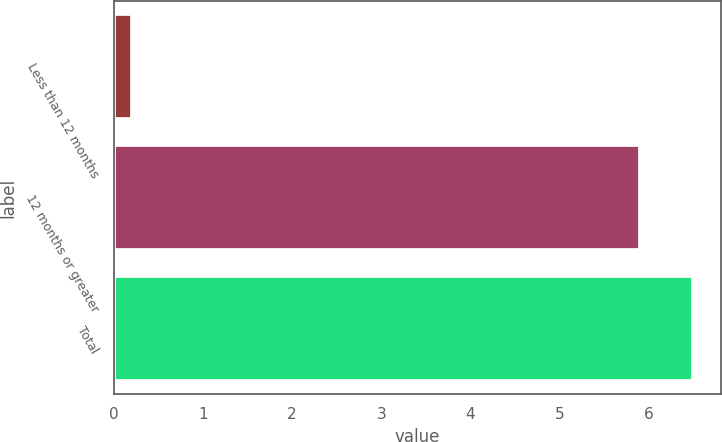Convert chart. <chart><loc_0><loc_0><loc_500><loc_500><bar_chart><fcel>Less than 12 months<fcel>12 months or greater<fcel>Total<nl><fcel>0.2<fcel>5.9<fcel>6.49<nl></chart> 